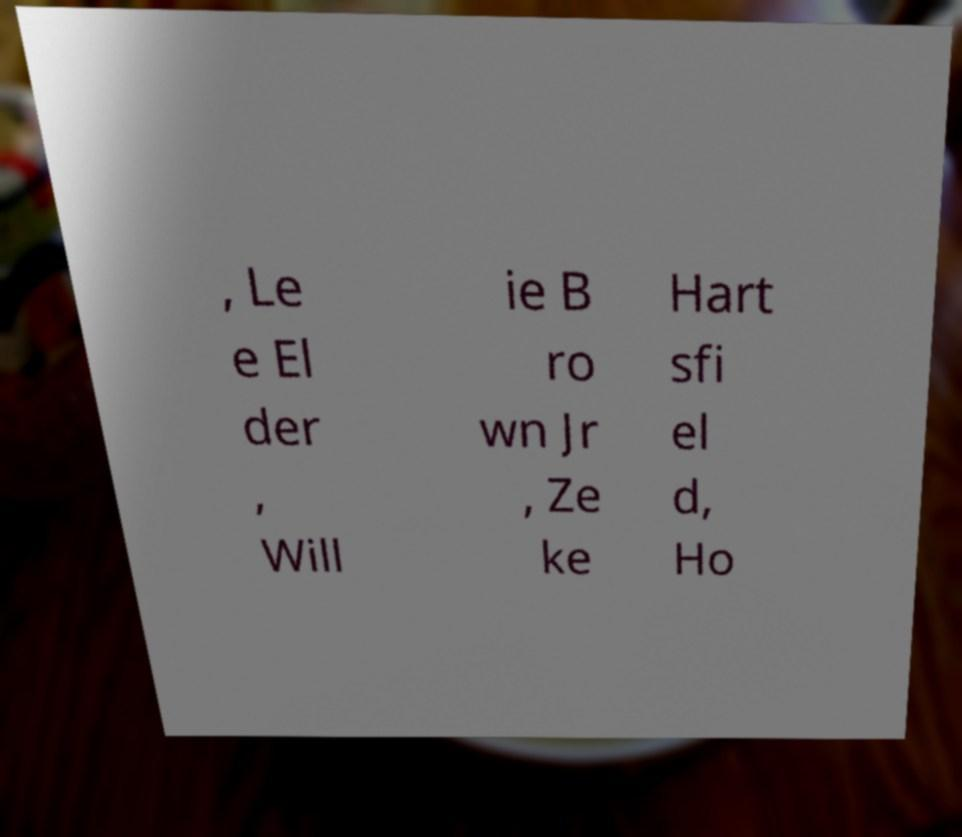Can you read and provide the text displayed in the image?This photo seems to have some interesting text. Can you extract and type it out for me? , Le e El der , Will ie B ro wn Jr , Ze ke Hart sfi el d, Ho 